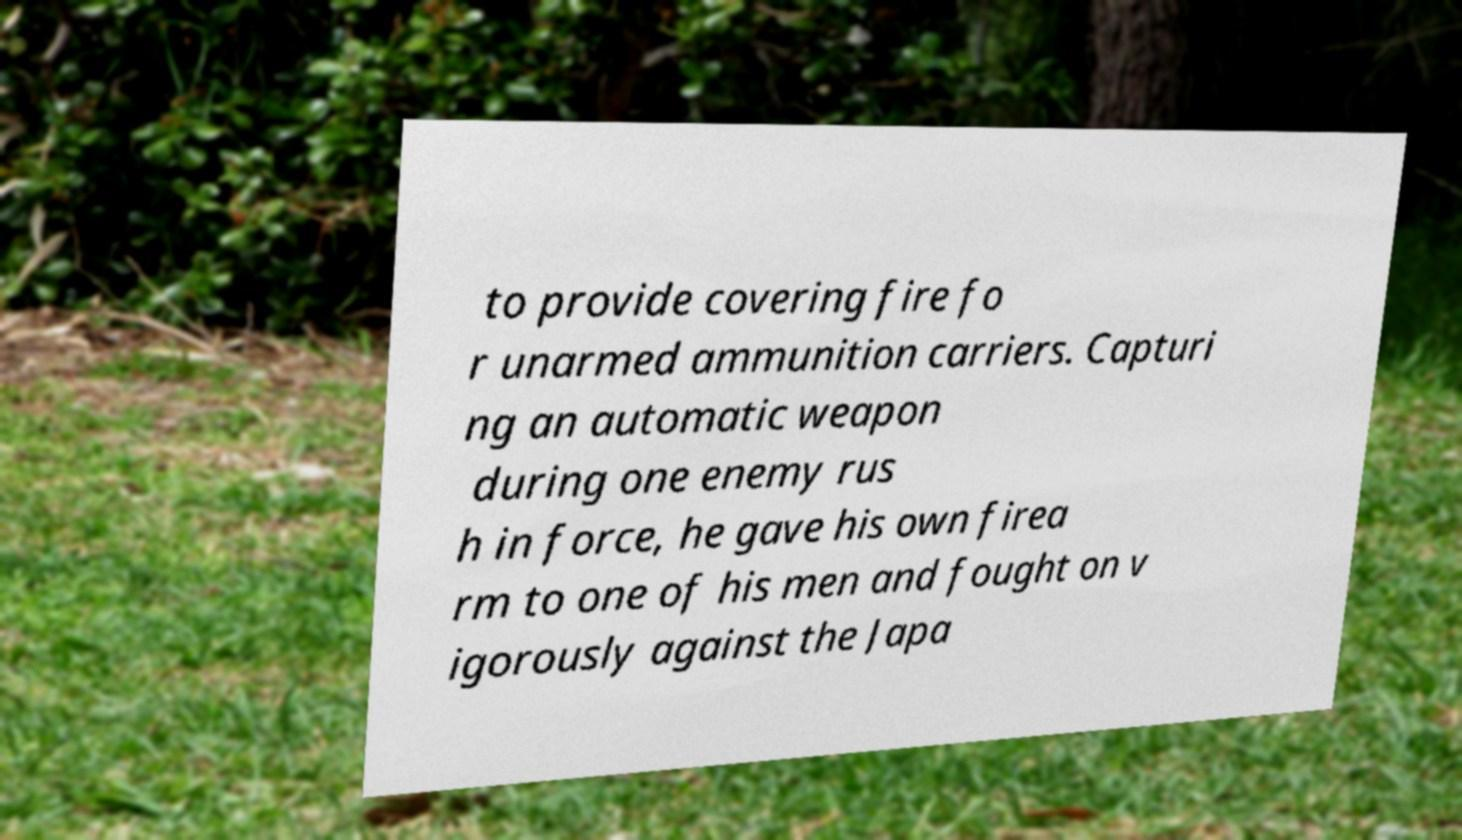I need the written content from this picture converted into text. Can you do that? to provide covering fire fo r unarmed ammunition carriers. Capturi ng an automatic weapon during one enemy rus h in force, he gave his own firea rm to one of his men and fought on v igorously against the Japa 